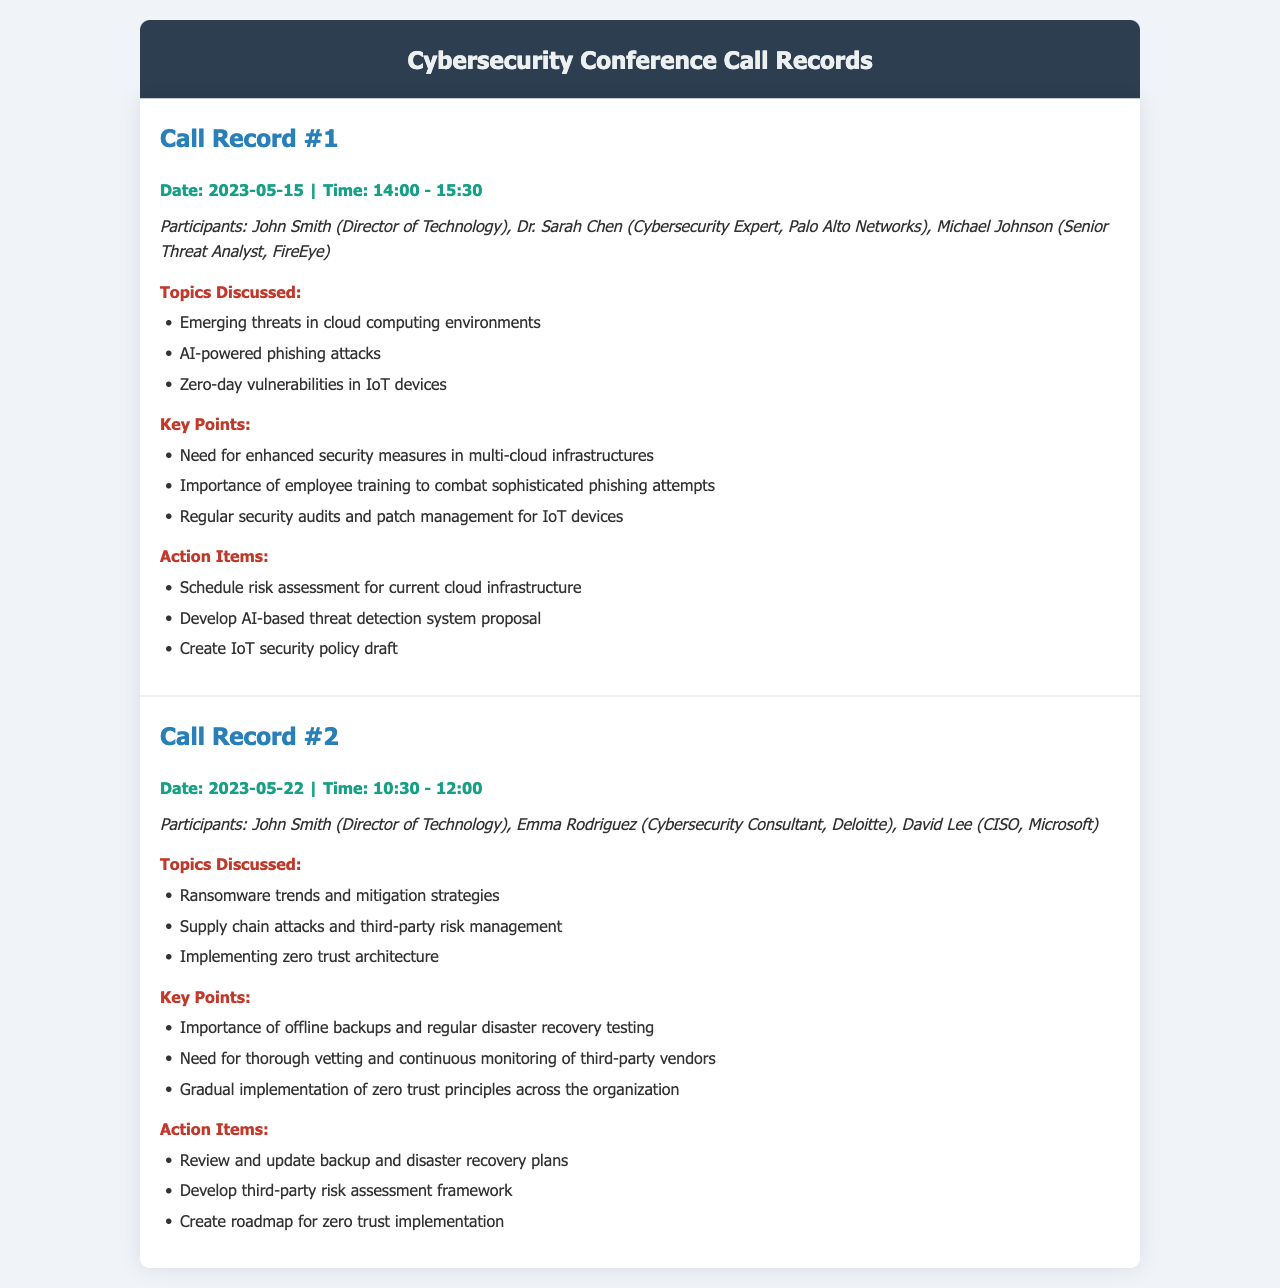What date was the first conference call held? The first conference call was held on May 15, 2023, as indicated in the document.
Answer: May 15, 2023 Who was one of the participants in the second call? The second call included Emma Rodriguez, as listed in the participants section.
Answer: Emma Rodriguez What was one of the main topics discussed in the first call? The main topics of the first call included AI-powered phishing attacks, among others mentioned.
Answer: AI-powered phishing attacks What is one action item from the second call? The second call had several action items, one of which was to create a roadmap for zero trust implementation.
Answer: Create roadmap for zero trust implementation How long was the duration of the first conference call? The first conference call lasted for 1 hour and 30 minutes, as noted by the start and end time.
Answer: 1 hour and 30 minutes What is the title of the document? The document is titled "Cybersecurity Conference Call Records," as seen at the top.
Answer: Cybersecurity Conference Call Records What was discussed in relation to IoT devices during the first call? The discussion included the need for regular security audits and patch management for IoT devices, highlighting its importance.
Answer: Regular security audits and patch management What was emphasized as a key point in the second call? One key point was the importance of offline backups and regular disaster recovery testing during the call.
Answer: Importance of offline backups and regular disaster recovery testing 